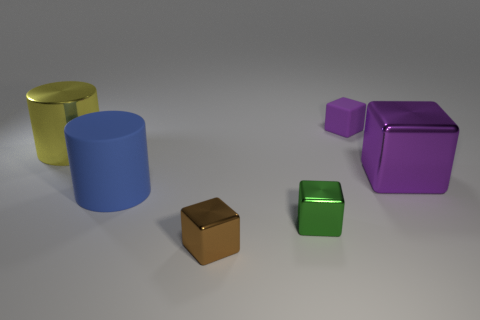There is another thing that is the same color as the small rubber object; what is it made of?
Provide a short and direct response. Metal. Do the green thing and the tiny thing behind the blue matte object have the same shape?
Provide a succinct answer. Yes. There is a small block behind the large rubber cylinder; what color is it?
Your answer should be compact. Purple. There is a metallic object that is on the left side of the tiny block to the left of the tiny green shiny block; how big is it?
Your answer should be compact. Large. Is the shape of the big object that is to the right of the green metallic object the same as  the big blue thing?
Your answer should be compact. No. What material is the yellow object that is the same shape as the blue object?
Offer a very short reply. Metal. How many things are cylinders behind the blue thing or rubber objects that are behind the blue cylinder?
Your response must be concise. 2. Does the large shiny cylinder have the same color as the big metallic thing that is on the right side of the large blue cylinder?
Your response must be concise. No. There is a brown object that is the same material as the big yellow thing; what shape is it?
Offer a terse response. Cube. What number of large blue matte cylinders are there?
Your answer should be compact. 1. 